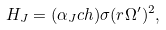Convert formula to latex. <formula><loc_0><loc_0><loc_500><loc_500>H _ { J } = ( \alpha _ { J } c h ) \sigma ( r \Omega ^ { \prime } ) ^ { 2 } ,</formula> 